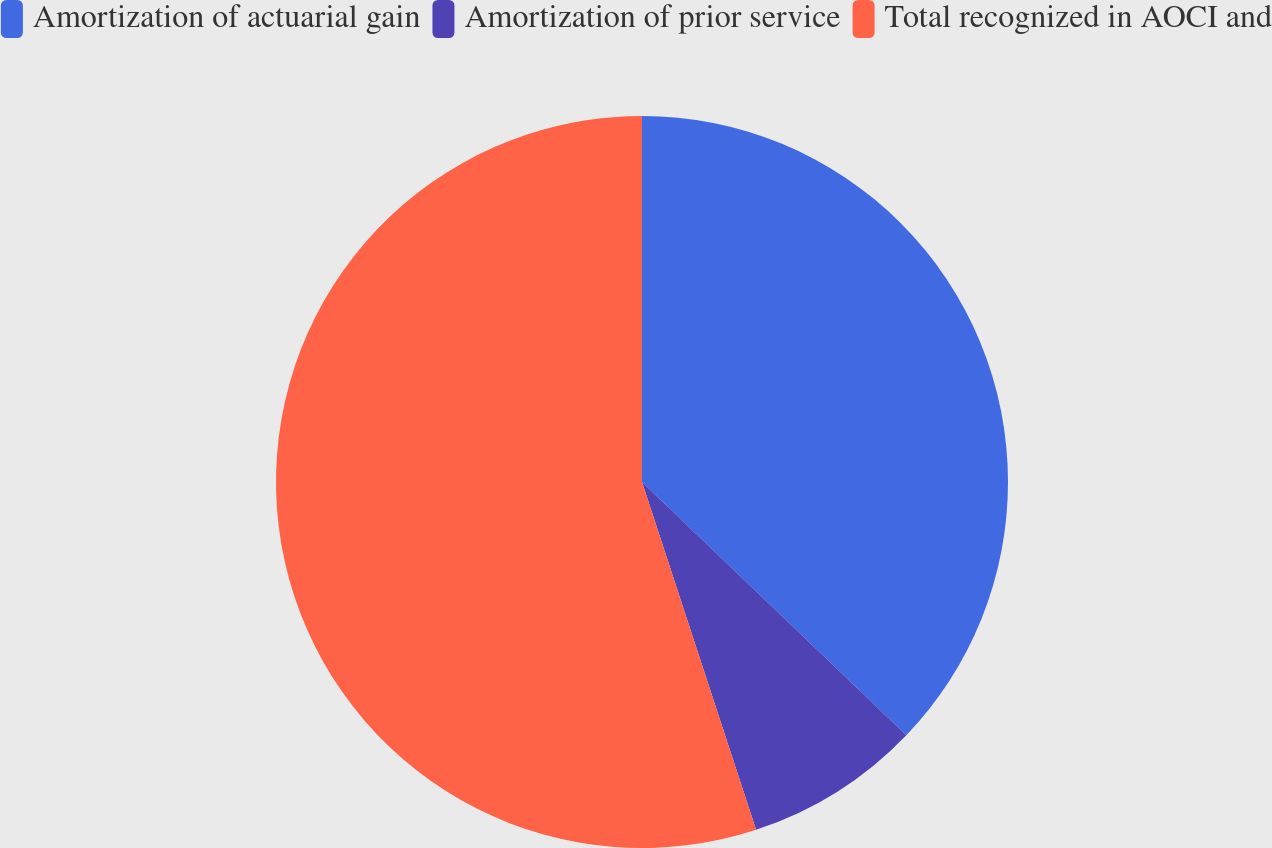<chart> <loc_0><loc_0><loc_500><loc_500><pie_chart><fcel>Amortization of actuarial gain<fcel>Amortization of prior service<fcel>Total recognized in AOCI and<nl><fcel>37.16%<fcel>7.8%<fcel>55.05%<nl></chart> 